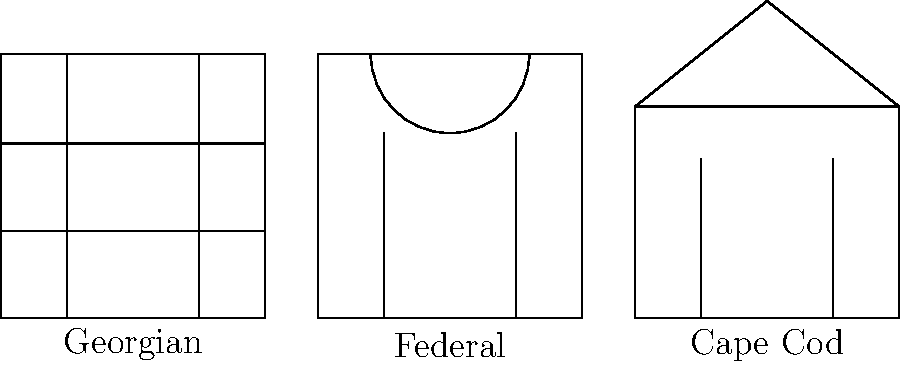As a community organizer planning a local event on colonial American history, you come across these diagrams of common architectural styles from the colonial era. Which style is characterized by a symmetrical facade with five openings on the front, including a central door, and typically features a semi-circular fanlight above the entrance? Let's analyze each architectural style shown in the diagram:

1. Georgian style:
   - Symmetrical facade
   - Three rows of windows
   - No distinctive entrance feature

2. Federal style:
   - Symmetrical facade
   - Semi-circular fanlight above the entrance
   - Two columns of windows flanking the central door

3. Cape Cod style:
   - Symmetrical facade
   - Steeply pitched roof
   - Central chimney (not shown in this simplified diagram)

The question asks for a style with a symmetrical facade, five openings on the front (including a central door), and a semi-circular fanlight above the entrance. 

The Federal style matches these characteristics perfectly:
- It has a symmetrical facade
- The diagram shows two columns of windows (4 openings) plus a central door, totaling 5 openings
- There is a distinctive semi-circular arc above the entrance, representing the fanlight

Therefore, the architectural style that fits the description is the Federal style.
Answer: Federal style 